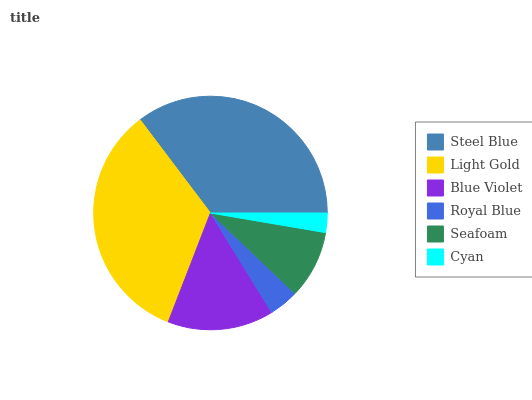Is Cyan the minimum?
Answer yes or no. Yes. Is Steel Blue the maximum?
Answer yes or no. Yes. Is Light Gold the minimum?
Answer yes or no. No. Is Light Gold the maximum?
Answer yes or no. No. Is Steel Blue greater than Light Gold?
Answer yes or no. Yes. Is Light Gold less than Steel Blue?
Answer yes or no. Yes. Is Light Gold greater than Steel Blue?
Answer yes or no. No. Is Steel Blue less than Light Gold?
Answer yes or no. No. Is Blue Violet the high median?
Answer yes or no. Yes. Is Seafoam the low median?
Answer yes or no. Yes. Is Seafoam the high median?
Answer yes or no. No. Is Cyan the low median?
Answer yes or no. No. 